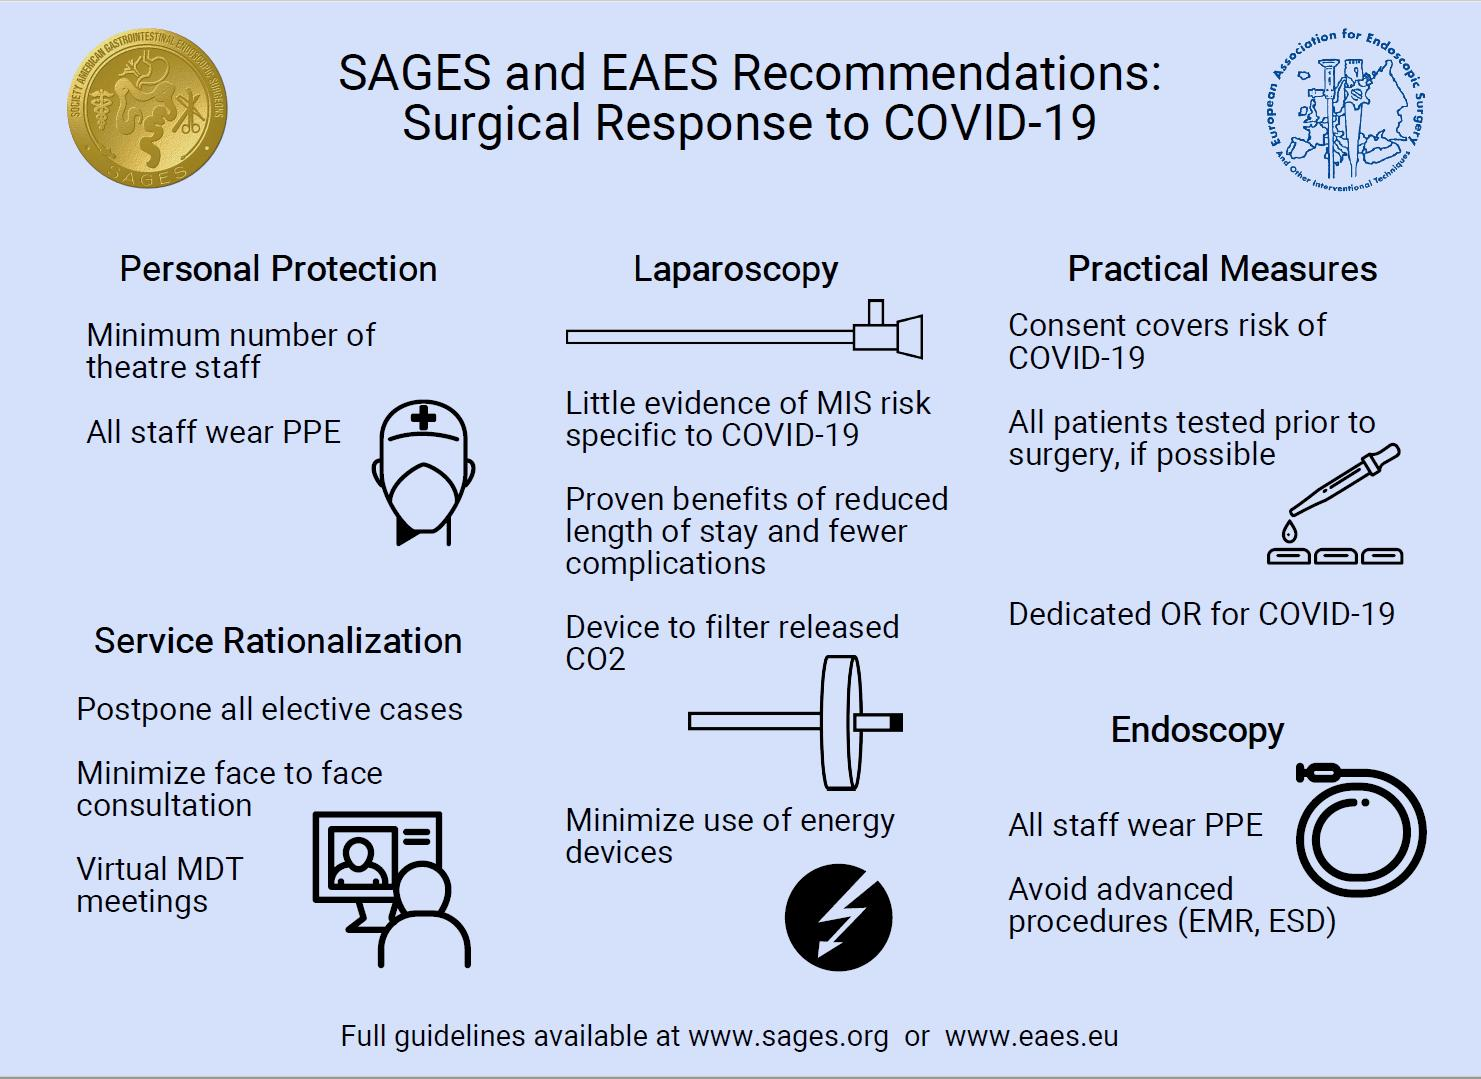Mention a couple of crucial points in this snapshot. Energy devices should be minimized in laparoscopy to ensure safe and effective procedure. The first recommendation listed under service rationalization is to postpone all elective cases. Virtual MDT meetings will be conducted as part of the Service Rationalization measure. The third recommendation under practical measures is to establish a dedicated COVID-19 operating room (OR) in hospitals. 